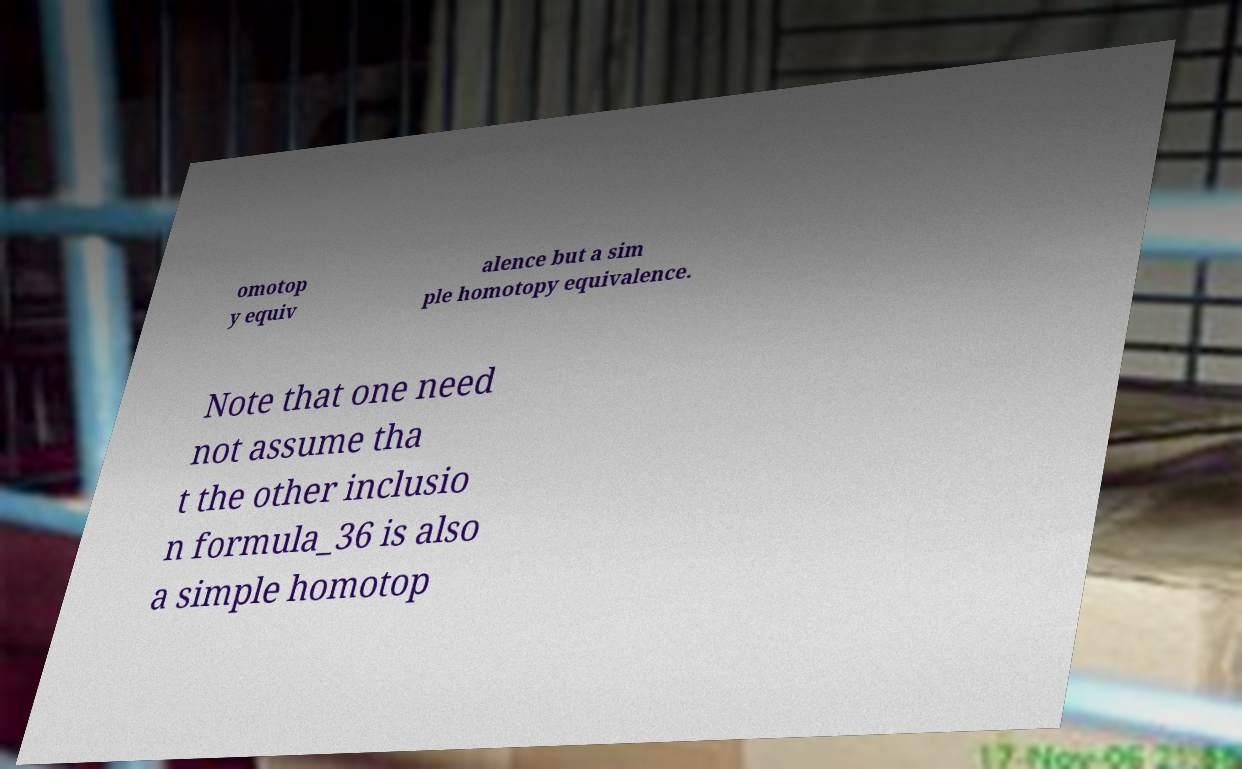There's text embedded in this image that I need extracted. Can you transcribe it verbatim? omotop y equiv alence but a sim ple homotopy equivalence. Note that one need not assume tha t the other inclusio n formula_36 is also a simple homotop 